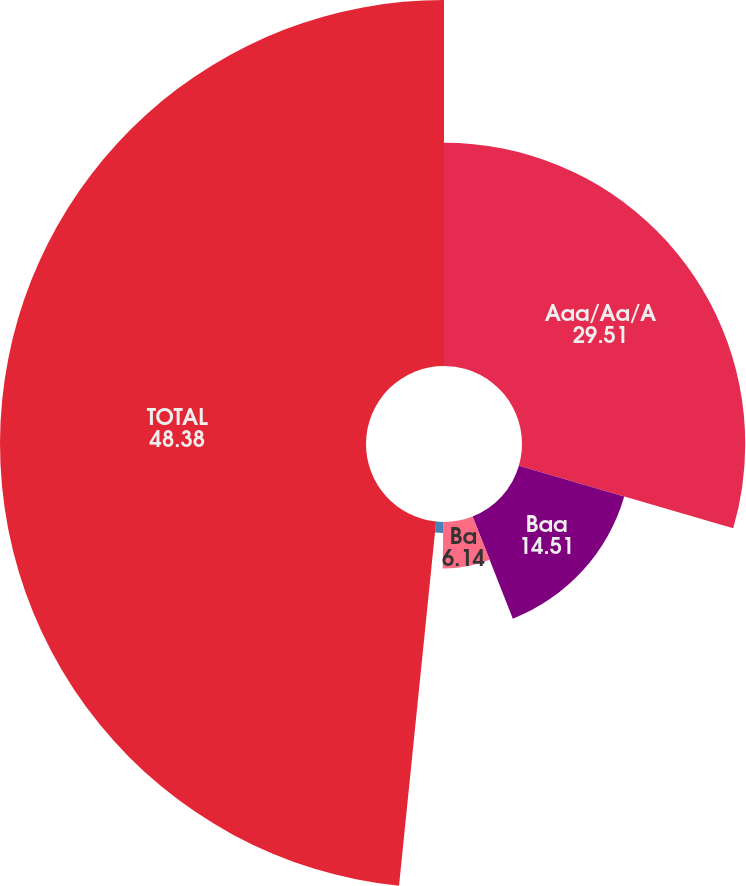Convert chart. <chart><loc_0><loc_0><loc_500><loc_500><pie_chart><fcel>Aaa/Aa/A<fcel>Baa<fcel>Ba<fcel>B and lower<fcel>TOTAL<nl><fcel>29.51%<fcel>14.51%<fcel>6.14%<fcel>1.45%<fcel>48.38%<nl></chart> 